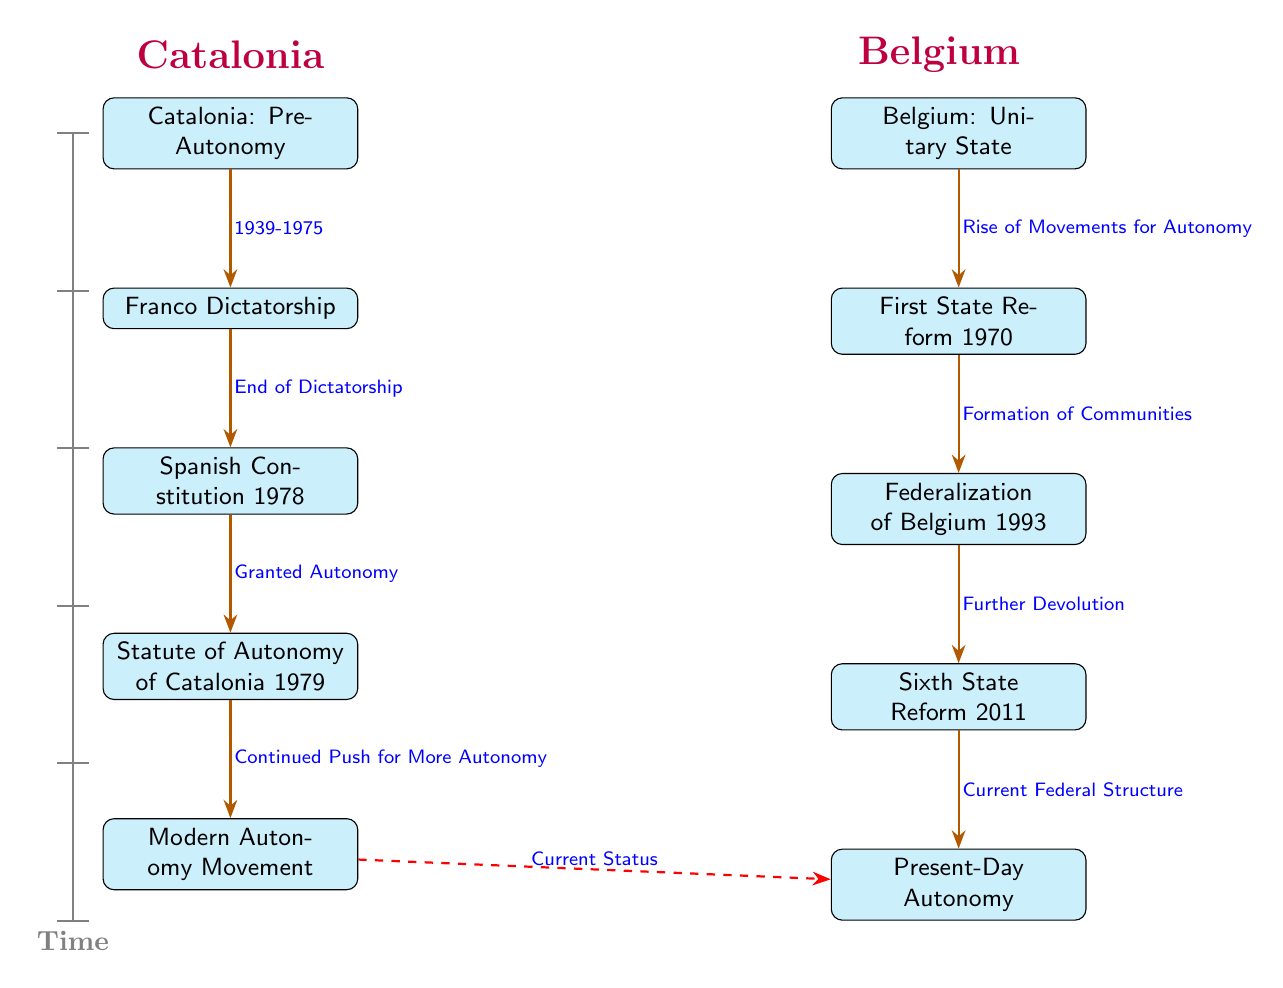What is the first event in the Catalonia timeline? The first event in the Catalonia timeline is located at the top of the column, which is marked as "Catalonia: Pre-Autonomy."
Answer: Catalonia: Pre-Autonomy What year marks the end of the Franco Dictatorship? The arrow between the nodes "Franco Dictatorship" and "Spanish Constitution 1978" indicates this is the point where the dictatorship ended, leading to the next significant event. The timeline suggests that this transition occurred around 1975.
Answer: 1975 How many main events are listed in the Belgium timeline? The Belgium timeline contains five main events: "Belgium: Unitary State," "First State Reform 1970," "Federalization of Belgium 1993," "Sixth State Reform 2011," and "Present-Day Autonomy."
Answer: 5 Which event directly follows the Statute of Autonomy of Catalonia 1979? The next event after "Statute of Autonomy of Catalonia 1979" in the diagram is "Modern Autonomy Movement," indicating a progressive push for autonomy thereafter.
Answer: Modern Autonomy Movement What is the relationship between the Modern Autonomy Movement and Present-Day Autonomy? The dashed red arrow represents a connection between these two events, indicating that the Modern Autonomy Movement reflects the current considerations and status of autonomy in Catalonia, leading towards Present-Day Autonomy.
Answer: Current Status What significant reform did Belgium undergo in 1993? From the timeline, the event that occurred in 1993 is called "Federalization of Belgium," which represents a major reform in the state structure of Belgium during that time.
Answer: Federalization of Belgium What event does "Granted Autonomy" correspond to in the Catalonia timeline? "Granted Autonomy" corresponds to the event "Statute of Autonomy of Catalonia 1979," which indicates the granting of self-government rights to Catalonia after the Spanish Constitution was enacted.
Answer: Statute of Autonomy of Catalonia 1979 Which event in Belgium's timeline follows the "Formation of Communities"? The event that directly follows "Formation of Communities" is "Federalization of Belgium 1993," signifying a move towards a more decentralized political structure in Belgium.
Answer: Federalization of Belgium 1993 What is the connecting event between the Franco Dictatorship and the Spanish Constitution? The connecting event is stated on the arrow as "End of Dictatorship," indicating the transition from the dictatorship to the establishment of the Spanish Constitution in 1978.
Answer: End of Dictatorship 